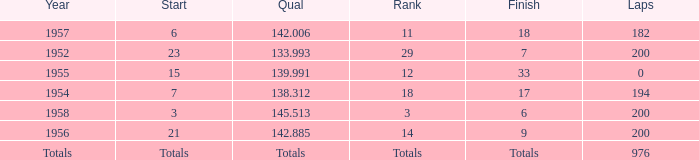What place did Jimmy Reece finish in 1957? 18.0. 